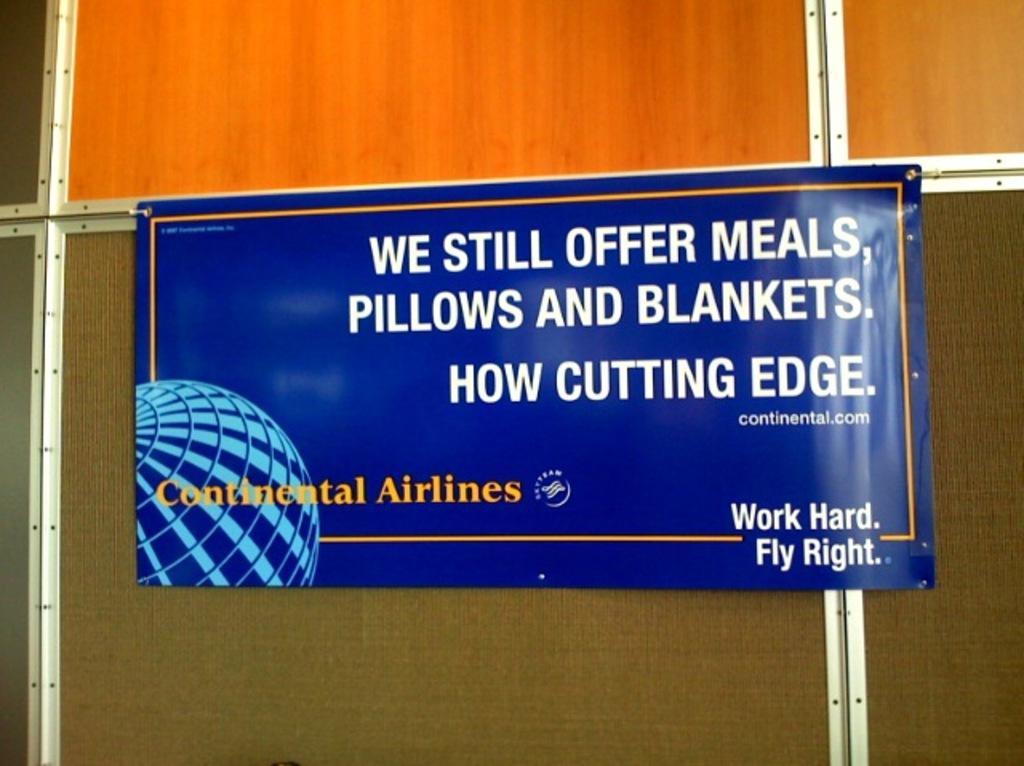What is offered by this airline?
Your answer should be compact. Meals, pillows and blankets. What is the slogan in the bottom right corner?
Ensure brevity in your answer.  Work hard fly right. 